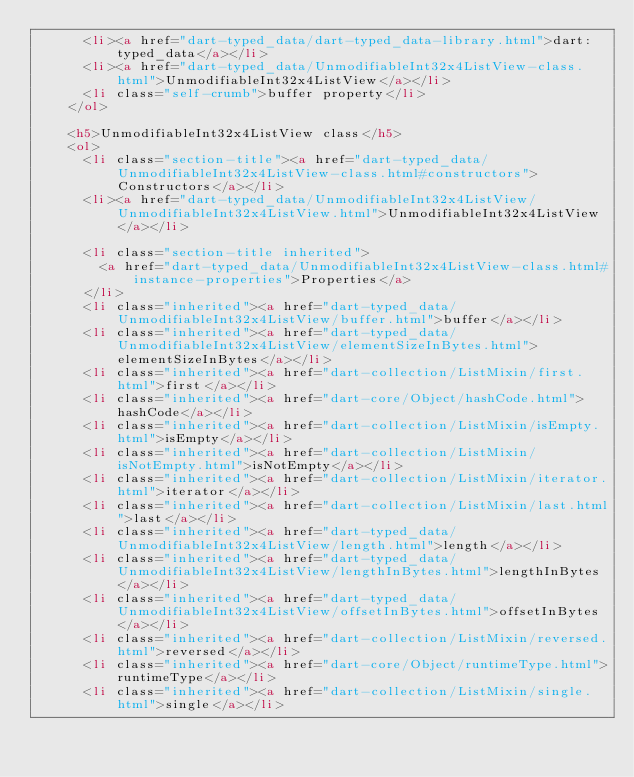<code> <loc_0><loc_0><loc_500><loc_500><_HTML_>      <li><a href="dart-typed_data/dart-typed_data-library.html">dart:typed_data</a></li>
      <li><a href="dart-typed_data/UnmodifiableInt32x4ListView-class.html">UnmodifiableInt32x4ListView</a></li>
      <li class="self-crumb">buffer property</li>
    </ol>
    
    <h5>UnmodifiableInt32x4ListView class</h5>
    <ol>
      <li class="section-title"><a href="dart-typed_data/UnmodifiableInt32x4ListView-class.html#constructors">Constructors</a></li>
      <li><a href="dart-typed_data/UnmodifiableInt32x4ListView/UnmodifiableInt32x4ListView.html">UnmodifiableInt32x4ListView</a></li>
    
      <li class="section-title inherited">
        <a href="dart-typed_data/UnmodifiableInt32x4ListView-class.html#instance-properties">Properties</a>
      </li>
      <li class="inherited"><a href="dart-typed_data/UnmodifiableInt32x4ListView/buffer.html">buffer</a></li>
      <li class="inherited"><a href="dart-typed_data/UnmodifiableInt32x4ListView/elementSizeInBytes.html">elementSizeInBytes</a></li>
      <li class="inherited"><a href="dart-collection/ListMixin/first.html">first</a></li>
      <li class="inherited"><a href="dart-core/Object/hashCode.html">hashCode</a></li>
      <li class="inherited"><a href="dart-collection/ListMixin/isEmpty.html">isEmpty</a></li>
      <li class="inherited"><a href="dart-collection/ListMixin/isNotEmpty.html">isNotEmpty</a></li>
      <li class="inherited"><a href="dart-collection/ListMixin/iterator.html">iterator</a></li>
      <li class="inherited"><a href="dart-collection/ListMixin/last.html">last</a></li>
      <li class="inherited"><a href="dart-typed_data/UnmodifiableInt32x4ListView/length.html">length</a></li>
      <li class="inherited"><a href="dart-typed_data/UnmodifiableInt32x4ListView/lengthInBytes.html">lengthInBytes</a></li>
      <li class="inherited"><a href="dart-typed_data/UnmodifiableInt32x4ListView/offsetInBytes.html">offsetInBytes</a></li>
      <li class="inherited"><a href="dart-collection/ListMixin/reversed.html">reversed</a></li>
      <li class="inherited"><a href="dart-core/Object/runtimeType.html">runtimeType</a></li>
      <li class="inherited"><a href="dart-collection/ListMixin/single.html">single</a></li>
    </code> 